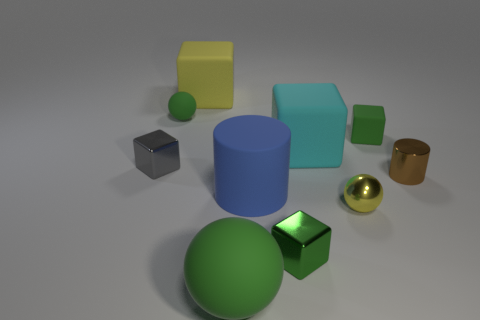Subtract all gray cubes. How many cubes are left? 4 Subtract all cyan cubes. How many cubes are left? 4 Subtract all blue blocks. Subtract all blue spheres. How many blocks are left? 5 Subtract all cylinders. How many objects are left? 8 Subtract 0 purple cylinders. How many objects are left? 10 Subtract all matte blocks. Subtract all big yellow metal cylinders. How many objects are left? 7 Add 7 tiny metallic blocks. How many tiny metallic blocks are left? 9 Add 7 tiny purple metal cylinders. How many tiny purple metal cylinders exist? 7 